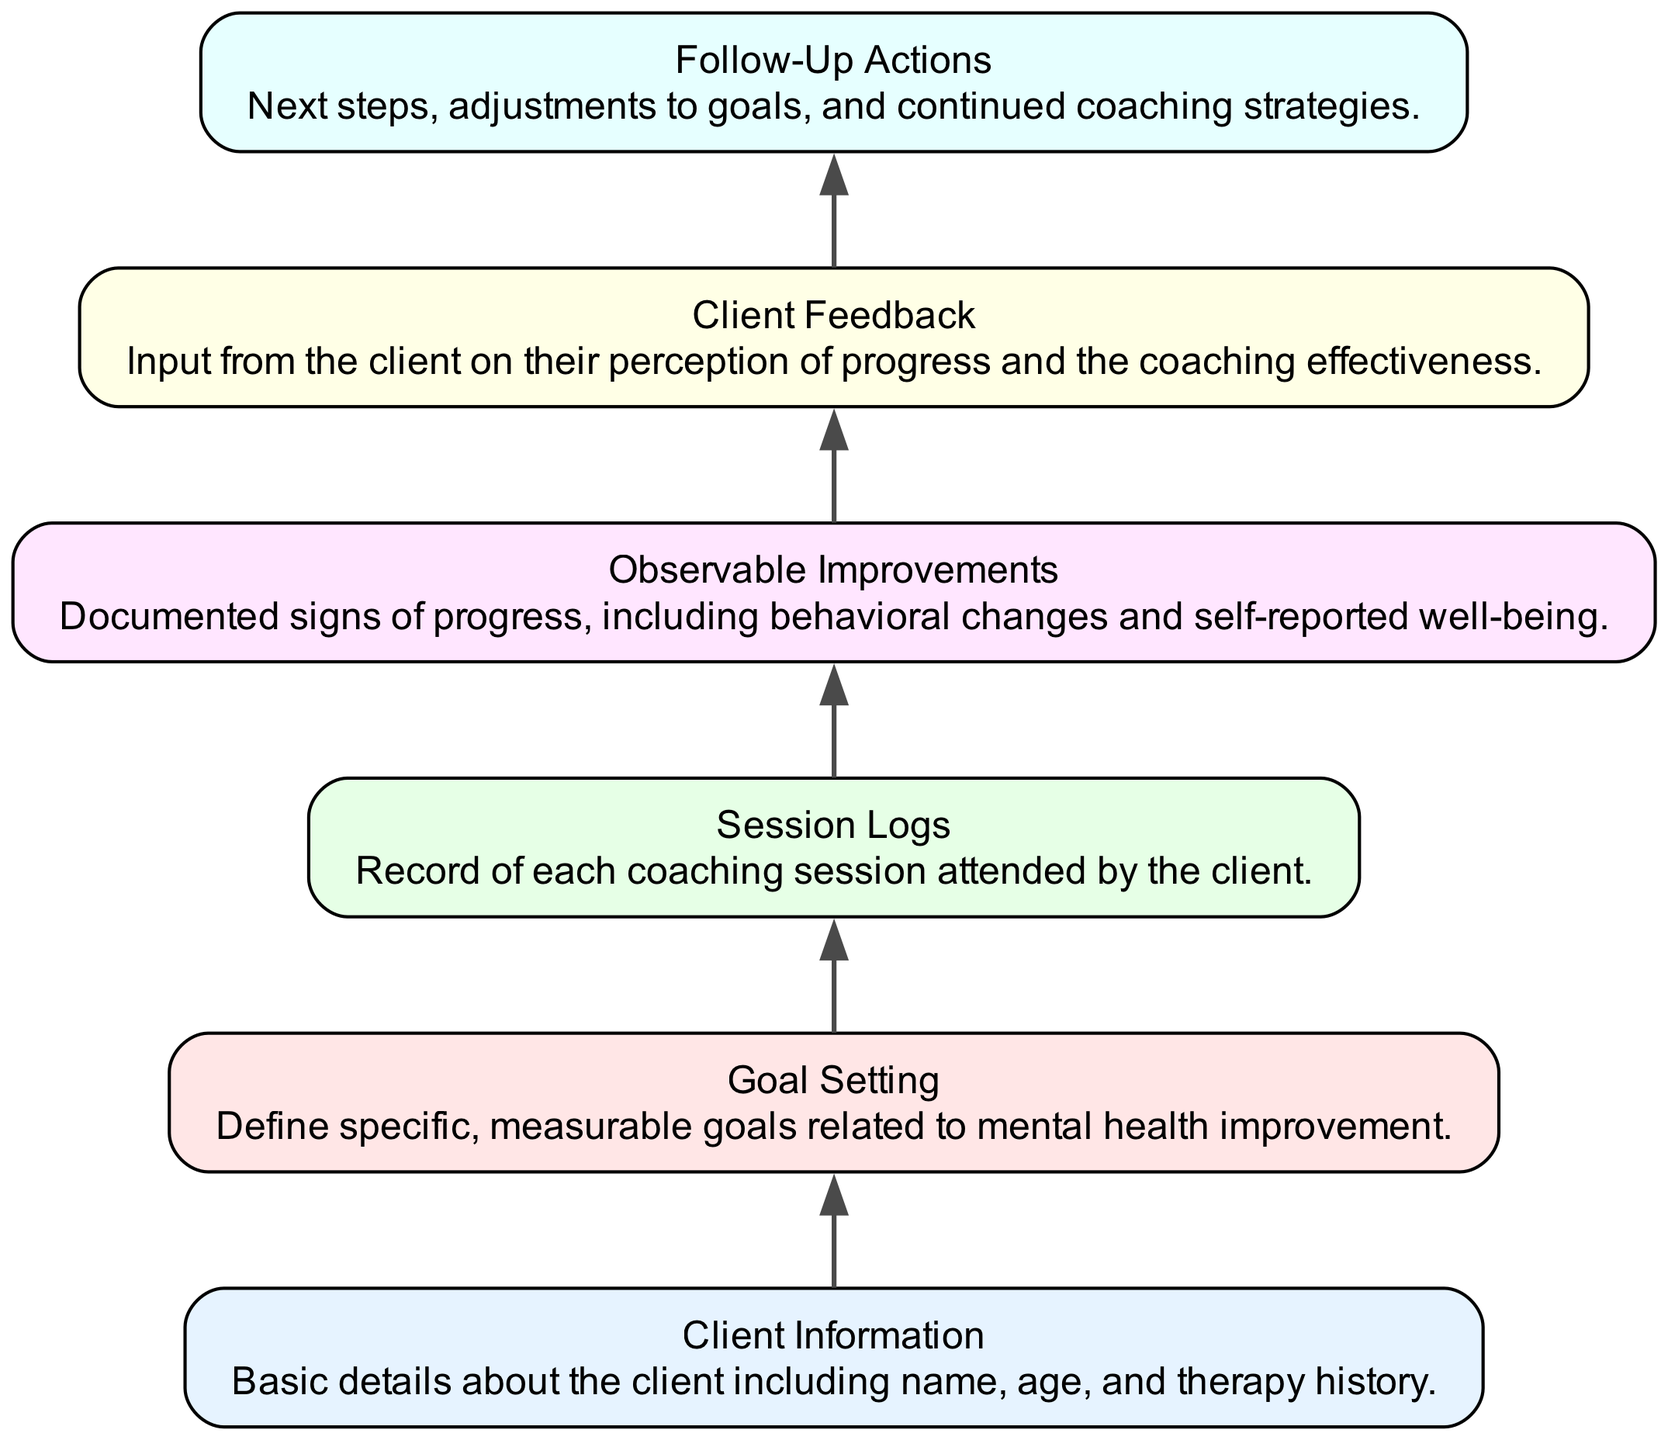What are the basic details included in client information? The "Client Information" node describes basic details about the client, which includes their name, age, and therapy history.
Answer: Basic details about the client including name, age, and therapy history How many goals are defined before coaching sessions? The diagram indicates that "Goal Setting" occurs after "Client Information," suggesting that at least one goal is set for each client. However, the exact number is not specified in the diagram.
Answer: Not specified What is the output of the first coaching session logged? "Session Logs" refers to the record of each coaching session attended. As such, there is no explicit output mentioned for the first session; rather, it serves as a starting point for tracking observable improvements.
Answer: Not specified What kind of progress is documented under observable improvements? "Observable Improvements" documents tangible signs of progress, which include behavioral changes and the client's self-reported sense of well-being.
Answer: Documented signs of progress, including behavioral changes and self-reported well-being What determines the follow-up actions in the coaching process? The "Follow-Up Actions" node processes input from the "Feedback" node, which captures client perceptions about their progress and the effectiveness of coaching. This feedback guides any necessary adjustments to goals or strategies in coaching.
Answer: Next steps, adjustments to goals, and continued coaching strategies How is client feedback utilized in the coaching process? Client feedback is collected in the "Client Feedback" node and directly influences the "Follow-Up Actions" node, where the coach assesses and adjusts the coaching approach based on client input.
Answer: Input from the client on their perception of progress and the coaching effectiveness What is the sequence of nodes leading to follow-up actions? The sequence leading to "Follow-Up Actions" is as follows: "Client Information" → "Goal Setting" → "Session Logs" → "Observable Improvements" → "Client Feedback." Each node represents a progressive step in the client's coaching journey.
Answer: Client Information, Goal Setting, Session Logs, Observable Improvements, Client Feedback Which node details the recording of each coaching session? The "Session Logs" node is specifically dedicated to recording each coaching session attended by the client.
Answer: Session Logs 